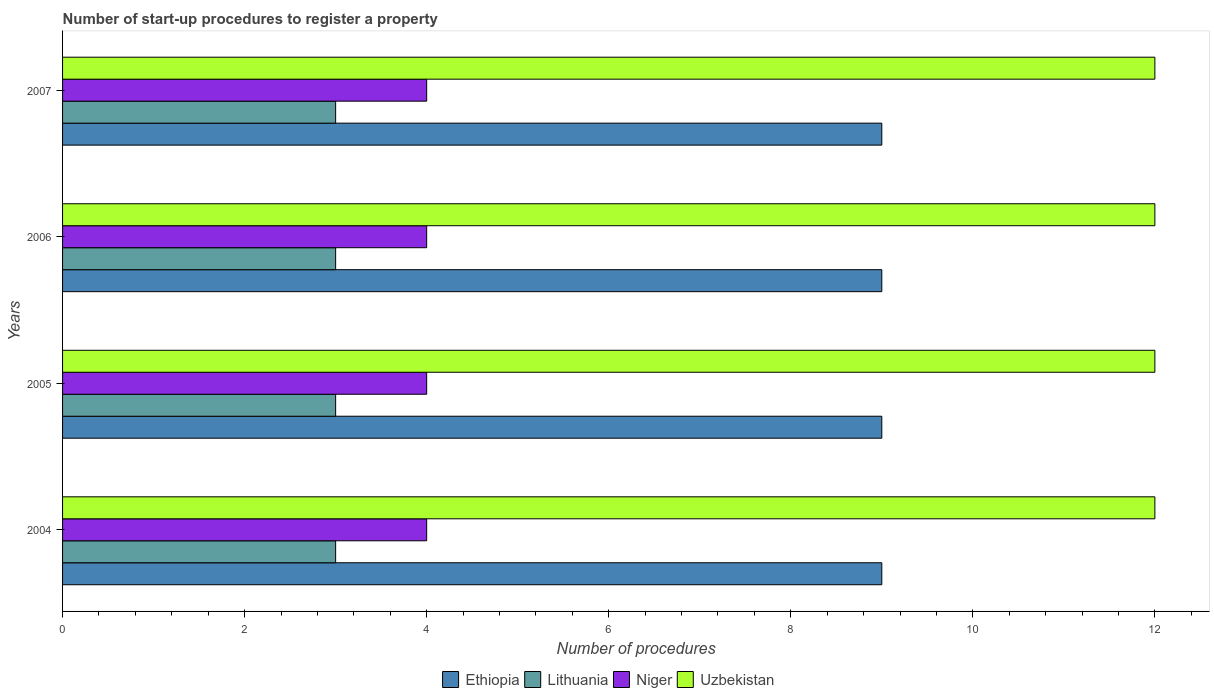How many bars are there on the 2nd tick from the top?
Offer a very short reply. 4. What is the number of procedures required to register a property in Lithuania in 2006?
Your answer should be compact. 3. Across all years, what is the maximum number of procedures required to register a property in Ethiopia?
Offer a very short reply. 9. Across all years, what is the minimum number of procedures required to register a property in Lithuania?
Ensure brevity in your answer.  3. In which year was the number of procedures required to register a property in Lithuania maximum?
Offer a terse response. 2004. In which year was the number of procedures required to register a property in Lithuania minimum?
Offer a terse response. 2004. What is the total number of procedures required to register a property in Lithuania in the graph?
Your answer should be compact. 12. What is the difference between the number of procedures required to register a property in Ethiopia in 2004 and that in 2007?
Provide a short and direct response. 0. What is the difference between the number of procedures required to register a property in Niger in 2004 and the number of procedures required to register a property in Uzbekistan in 2005?
Provide a succinct answer. -8. In the year 2005, what is the difference between the number of procedures required to register a property in Niger and number of procedures required to register a property in Lithuania?
Offer a very short reply. 1. Is the number of procedures required to register a property in Niger in 2005 less than that in 2006?
Make the answer very short. No. What is the difference between the highest and the second highest number of procedures required to register a property in Lithuania?
Give a very brief answer. 0. What is the difference between the highest and the lowest number of procedures required to register a property in Ethiopia?
Your response must be concise. 0. In how many years, is the number of procedures required to register a property in Uzbekistan greater than the average number of procedures required to register a property in Uzbekistan taken over all years?
Provide a succinct answer. 0. Is the sum of the number of procedures required to register a property in Niger in 2006 and 2007 greater than the maximum number of procedures required to register a property in Lithuania across all years?
Your response must be concise. Yes. Is it the case that in every year, the sum of the number of procedures required to register a property in Niger and number of procedures required to register a property in Uzbekistan is greater than the sum of number of procedures required to register a property in Lithuania and number of procedures required to register a property in Ethiopia?
Your answer should be compact. Yes. What does the 4th bar from the top in 2005 represents?
Provide a succinct answer. Ethiopia. What does the 3rd bar from the bottom in 2007 represents?
Offer a terse response. Niger. Is it the case that in every year, the sum of the number of procedures required to register a property in Niger and number of procedures required to register a property in Lithuania is greater than the number of procedures required to register a property in Ethiopia?
Offer a very short reply. No. How many years are there in the graph?
Your response must be concise. 4. What is the difference between two consecutive major ticks on the X-axis?
Your answer should be very brief. 2. Are the values on the major ticks of X-axis written in scientific E-notation?
Offer a very short reply. No. Does the graph contain any zero values?
Your answer should be very brief. No. What is the title of the graph?
Ensure brevity in your answer.  Number of start-up procedures to register a property. What is the label or title of the X-axis?
Your response must be concise. Number of procedures. What is the label or title of the Y-axis?
Provide a succinct answer. Years. What is the Number of procedures in Lithuania in 2004?
Offer a terse response. 3. What is the Number of procedures in Ethiopia in 2005?
Your answer should be very brief. 9. What is the Number of procedures of Lithuania in 2005?
Make the answer very short. 3. What is the Number of procedures of Lithuania in 2006?
Your answer should be compact. 3. What is the Number of procedures in Niger in 2006?
Offer a terse response. 4. What is the Number of procedures of Lithuania in 2007?
Your answer should be compact. 3. What is the Number of procedures of Niger in 2007?
Your answer should be very brief. 4. What is the Number of procedures of Uzbekistan in 2007?
Give a very brief answer. 12. Across all years, what is the minimum Number of procedures in Ethiopia?
Provide a short and direct response. 9. Across all years, what is the minimum Number of procedures of Lithuania?
Make the answer very short. 3. Across all years, what is the minimum Number of procedures of Uzbekistan?
Keep it short and to the point. 12. What is the total Number of procedures in Ethiopia in the graph?
Provide a short and direct response. 36. What is the total Number of procedures in Niger in the graph?
Provide a short and direct response. 16. What is the total Number of procedures in Uzbekistan in the graph?
Your response must be concise. 48. What is the difference between the Number of procedures of Uzbekistan in 2004 and that in 2005?
Keep it short and to the point. 0. What is the difference between the Number of procedures in Lithuania in 2004 and that in 2006?
Ensure brevity in your answer.  0. What is the difference between the Number of procedures in Niger in 2004 and that in 2006?
Keep it short and to the point. 0. What is the difference between the Number of procedures in Ethiopia in 2004 and that in 2007?
Offer a very short reply. 0. What is the difference between the Number of procedures in Lithuania in 2004 and that in 2007?
Your answer should be compact. 0. What is the difference between the Number of procedures in Niger in 2004 and that in 2007?
Provide a succinct answer. 0. What is the difference between the Number of procedures in Lithuania in 2005 and that in 2007?
Ensure brevity in your answer.  0. What is the difference between the Number of procedures in Uzbekistan in 2005 and that in 2007?
Your response must be concise. 0. What is the difference between the Number of procedures of Ethiopia in 2004 and the Number of procedures of Lithuania in 2005?
Your answer should be compact. 6. What is the difference between the Number of procedures in Ethiopia in 2004 and the Number of procedures in Niger in 2005?
Your answer should be very brief. 5. What is the difference between the Number of procedures in Lithuania in 2004 and the Number of procedures in Niger in 2005?
Ensure brevity in your answer.  -1. What is the difference between the Number of procedures of Lithuania in 2004 and the Number of procedures of Uzbekistan in 2005?
Your response must be concise. -9. What is the difference between the Number of procedures of Niger in 2004 and the Number of procedures of Uzbekistan in 2005?
Your answer should be very brief. -8. What is the difference between the Number of procedures in Ethiopia in 2004 and the Number of procedures in Lithuania in 2006?
Offer a terse response. 6. What is the difference between the Number of procedures of Ethiopia in 2004 and the Number of procedures of Niger in 2006?
Give a very brief answer. 5. What is the difference between the Number of procedures in Lithuania in 2004 and the Number of procedures in Niger in 2006?
Your response must be concise. -1. What is the difference between the Number of procedures in Ethiopia in 2004 and the Number of procedures in Niger in 2007?
Give a very brief answer. 5. What is the difference between the Number of procedures in Lithuania in 2004 and the Number of procedures in Niger in 2007?
Ensure brevity in your answer.  -1. What is the difference between the Number of procedures of Ethiopia in 2005 and the Number of procedures of Lithuania in 2006?
Provide a short and direct response. 6. What is the difference between the Number of procedures in Ethiopia in 2005 and the Number of procedures in Niger in 2006?
Keep it short and to the point. 5. What is the difference between the Number of procedures of Ethiopia in 2005 and the Number of procedures of Uzbekistan in 2006?
Offer a terse response. -3. What is the difference between the Number of procedures of Lithuania in 2005 and the Number of procedures of Niger in 2006?
Keep it short and to the point. -1. What is the difference between the Number of procedures of Ethiopia in 2005 and the Number of procedures of Lithuania in 2007?
Make the answer very short. 6. What is the difference between the Number of procedures in Ethiopia in 2005 and the Number of procedures in Uzbekistan in 2007?
Ensure brevity in your answer.  -3. What is the difference between the Number of procedures in Niger in 2005 and the Number of procedures in Uzbekistan in 2007?
Offer a terse response. -8. What is the difference between the Number of procedures of Ethiopia in 2006 and the Number of procedures of Lithuania in 2007?
Your answer should be compact. 6. What is the difference between the Number of procedures of Ethiopia in 2006 and the Number of procedures of Uzbekistan in 2007?
Provide a succinct answer. -3. What is the difference between the Number of procedures of Lithuania in 2006 and the Number of procedures of Uzbekistan in 2007?
Give a very brief answer. -9. What is the average Number of procedures in Lithuania per year?
Your answer should be compact. 3. What is the average Number of procedures of Uzbekistan per year?
Keep it short and to the point. 12. In the year 2004, what is the difference between the Number of procedures in Ethiopia and Number of procedures in Uzbekistan?
Provide a succinct answer. -3. In the year 2004, what is the difference between the Number of procedures of Lithuania and Number of procedures of Niger?
Keep it short and to the point. -1. In the year 2004, what is the difference between the Number of procedures in Lithuania and Number of procedures in Uzbekistan?
Your response must be concise. -9. In the year 2005, what is the difference between the Number of procedures of Ethiopia and Number of procedures of Lithuania?
Offer a terse response. 6. In the year 2005, what is the difference between the Number of procedures in Ethiopia and Number of procedures in Uzbekistan?
Your answer should be very brief. -3. In the year 2005, what is the difference between the Number of procedures in Lithuania and Number of procedures in Niger?
Make the answer very short. -1. In the year 2005, what is the difference between the Number of procedures in Lithuania and Number of procedures in Uzbekistan?
Provide a succinct answer. -9. In the year 2005, what is the difference between the Number of procedures in Niger and Number of procedures in Uzbekistan?
Offer a very short reply. -8. In the year 2006, what is the difference between the Number of procedures of Ethiopia and Number of procedures of Niger?
Offer a very short reply. 5. In the year 2006, what is the difference between the Number of procedures of Lithuania and Number of procedures of Niger?
Your response must be concise. -1. In the year 2007, what is the difference between the Number of procedures of Ethiopia and Number of procedures of Lithuania?
Make the answer very short. 6. In the year 2007, what is the difference between the Number of procedures in Ethiopia and Number of procedures in Uzbekistan?
Offer a terse response. -3. In the year 2007, what is the difference between the Number of procedures in Lithuania and Number of procedures in Niger?
Provide a short and direct response. -1. In the year 2007, what is the difference between the Number of procedures of Lithuania and Number of procedures of Uzbekistan?
Your response must be concise. -9. In the year 2007, what is the difference between the Number of procedures of Niger and Number of procedures of Uzbekistan?
Your answer should be compact. -8. What is the ratio of the Number of procedures in Uzbekistan in 2004 to that in 2005?
Your answer should be very brief. 1. What is the ratio of the Number of procedures of Ethiopia in 2004 to that in 2006?
Your answer should be compact. 1. What is the ratio of the Number of procedures of Lithuania in 2004 to that in 2006?
Your answer should be very brief. 1. What is the ratio of the Number of procedures of Uzbekistan in 2004 to that in 2006?
Offer a very short reply. 1. What is the ratio of the Number of procedures of Uzbekistan in 2004 to that in 2007?
Provide a succinct answer. 1. What is the ratio of the Number of procedures of Ethiopia in 2005 to that in 2006?
Your response must be concise. 1. What is the ratio of the Number of procedures in Lithuania in 2005 to that in 2006?
Offer a terse response. 1. What is the ratio of the Number of procedures of Niger in 2005 to that in 2006?
Provide a succinct answer. 1. What is the ratio of the Number of procedures of Lithuania in 2006 to that in 2007?
Provide a short and direct response. 1. What is the ratio of the Number of procedures in Niger in 2006 to that in 2007?
Your response must be concise. 1. What is the difference between the highest and the second highest Number of procedures in Ethiopia?
Give a very brief answer. 0. What is the difference between the highest and the second highest Number of procedures in Lithuania?
Give a very brief answer. 0. What is the difference between the highest and the second highest Number of procedures of Niger?
Your response must be concise. 0. What is the difference between the highest and the second highest Number of procedures in Uzbekistan?
Your answer should be compact. 0. What is the difference between the highest and the lowest Number of procedures in Ethiopia?
Ensure brevity in your answer.  0. What is the difference between the highest and the lowest Number of procedures in Niger?
Ensure brevity in your answer.  0. 